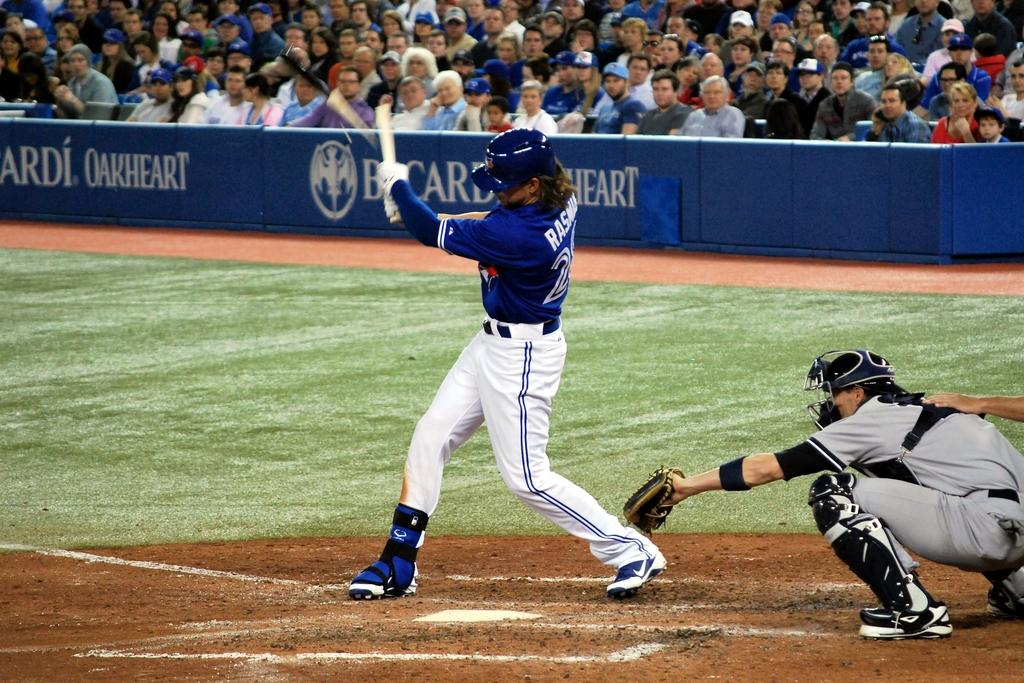<image>
Describe the image concisely. A baseball game is underway with a packed stadium that says Bacardi Oakheart. 